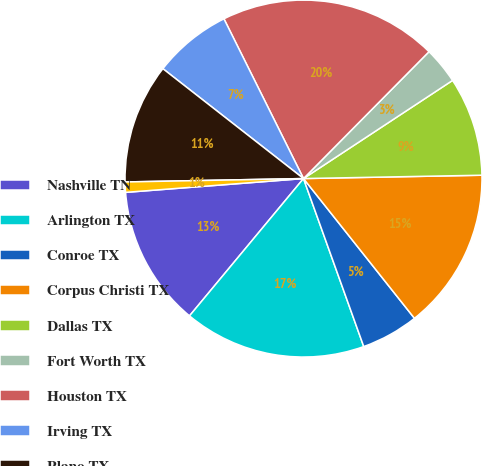Convert chart to OTSL. <chart><loc_0><loc_0><loc_500><loc_500><pie_chart><fcel>Nashville TN<fcel>Arlington TX<fcel>Conroe TX<fcel>Corpus Christi TX<fcel>Dallas TX<fcel>Fort Worth TX<fcel>Houston TX<fcel>Irving TX<fcel>Plano TX<fcel>Centerville UT<nl><fcel>12.74%<fcel>16.51%<fcel>5.2%<fcel>14.62%<fcel>8.97%<fcel>3.32%<fcel>19.77%<fcel>7.09%<fcel>10.86%<fcel>0.93%<nl></chart> 